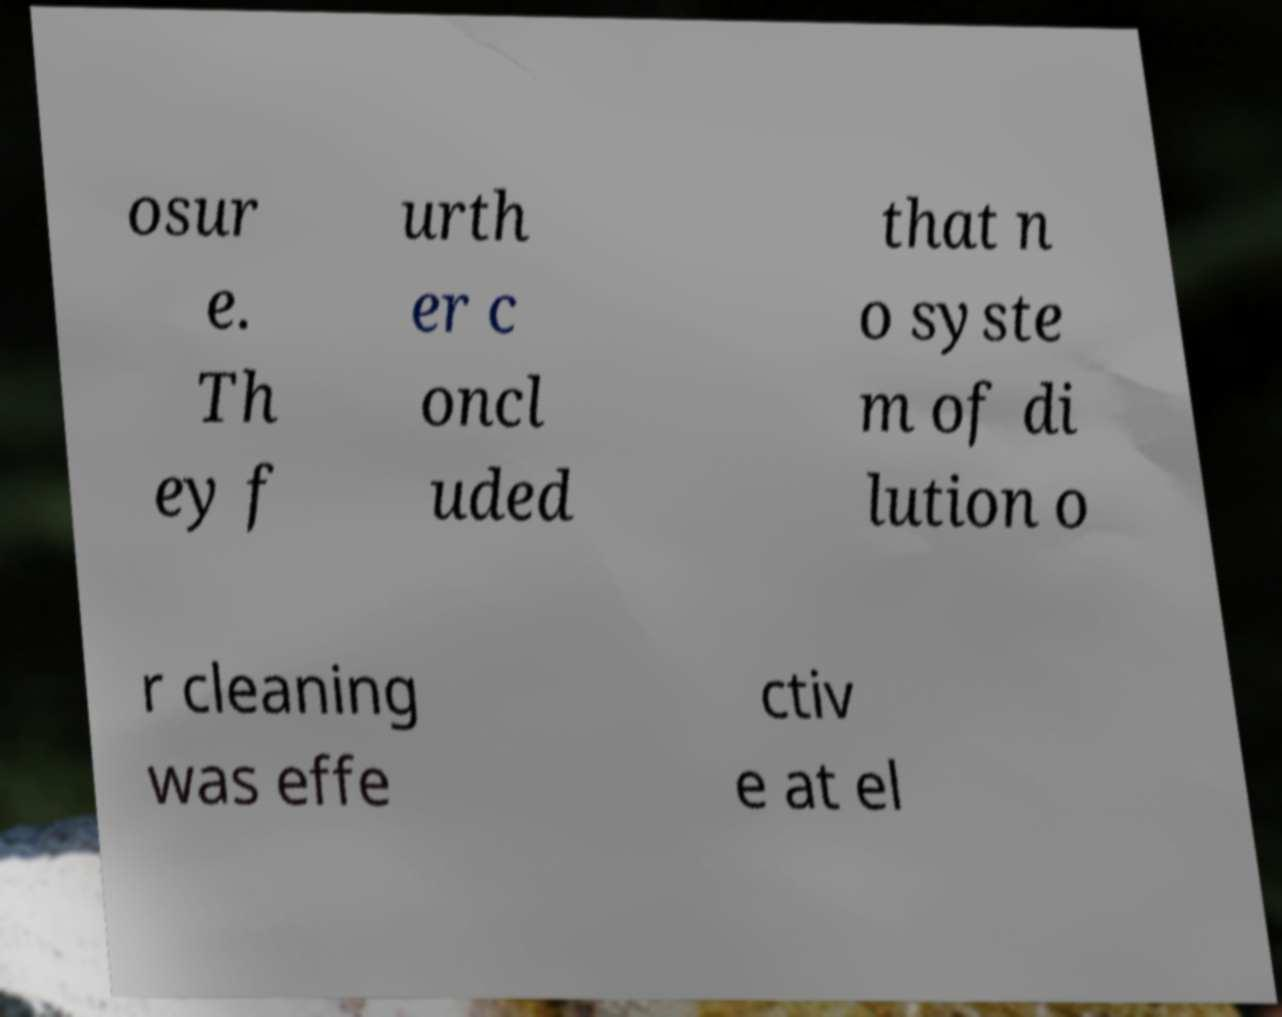For documentation purposes, I need the text within this image transcribed. Could you provide that? osur e. Th ey f urth er c oncl uded that n o syste m of di lution o r cleaning was effe ctiv e at el 